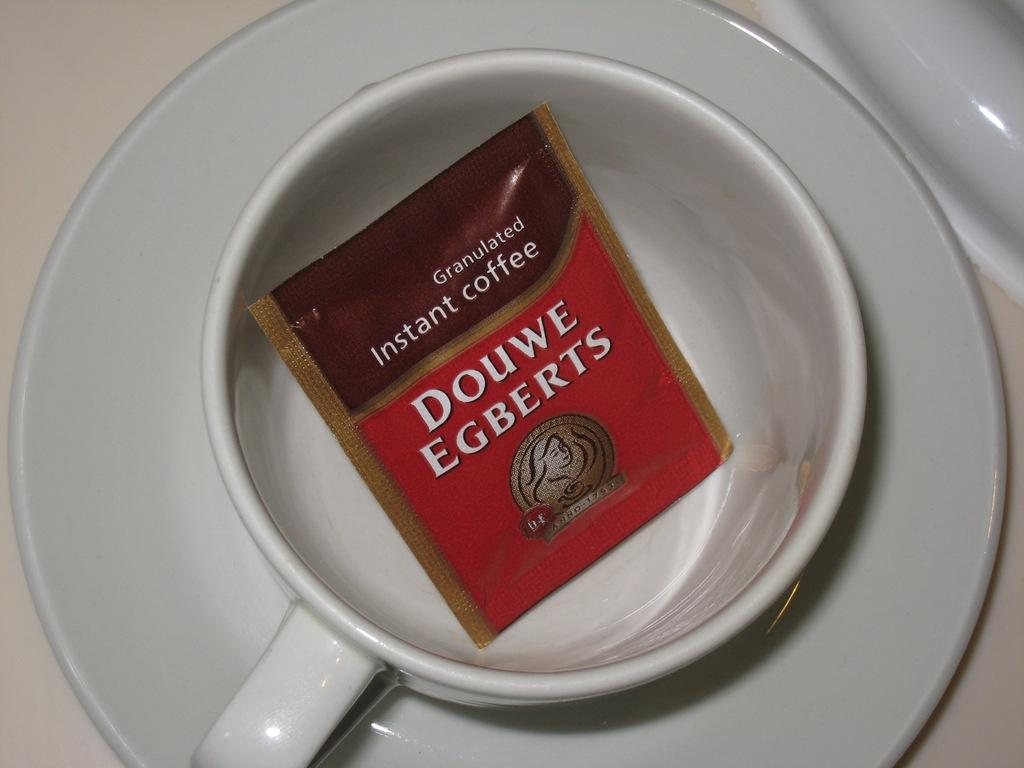What type of container is visible in the image? There is a white cup in the image. Is there any other object associated with the cup? Yes, there is a saucer associated with the cup. What is inside the cup? There is a packet inside the cup. Can you read what is written on the packet? The packet has something written on it, but the specific text is not visible in the image. Where is the giraffe located in the image? There is no giraffe present in the image. What type of yard is visible in the image? There is no yard visible in the image. 